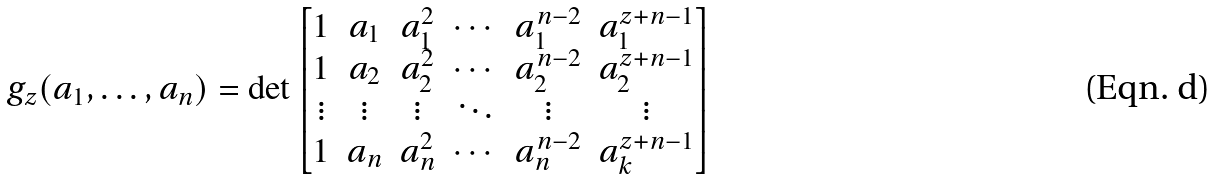<formula> <loc_0><loc_0><loc_500><loc_500>g _ { z } ( a _ { 1 } , \dots , a _ { n } ) = \det \begin{bmatrix} 1 & a _ { 1 } & a _ { 1 } ^ { 2 } & \cdots & a _ { 1 } ^ { n - 2 } & a _ { 1 } ^ { z + n - 1 } \\ 1 & a _ { 2 } & a _ { 2 } ^ { 2 } & \cdots & a _ { 2 } ^ { n - 2 } & a _ { 2 } ^ { z + n - 1 } \\ \vdots & \vdots & \vdots & \ddots & \vdots & \vdots \\ 1 & a _ { n } & a _ { n } ^ { 2 } & \cdots & a _ { n } ^ { n - 2 } & a _ { k } ^ { z + n - 1 } \\ \end{bmatrix}</formula> 